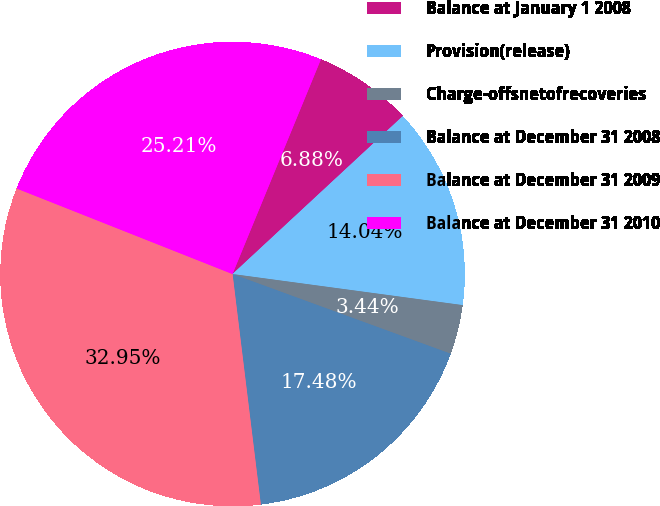<chart> <loc_0><loc_0><loc_500><loc_500><pie_chart><fcel>Balance at January 1 2008<fcel>Provision(release)<fcel>Charge-offsnetofrecoveries<fcel>Balance at December 31 2008<fcel>Balance at December 31 2009<fcel>Balance at December 31 2010<nl><fcel>6.88%<fcel>14.04%<fcel>3.44%<fcel>17.48%<fcel>32.95%<fcel>25.21%<nl></chart> 